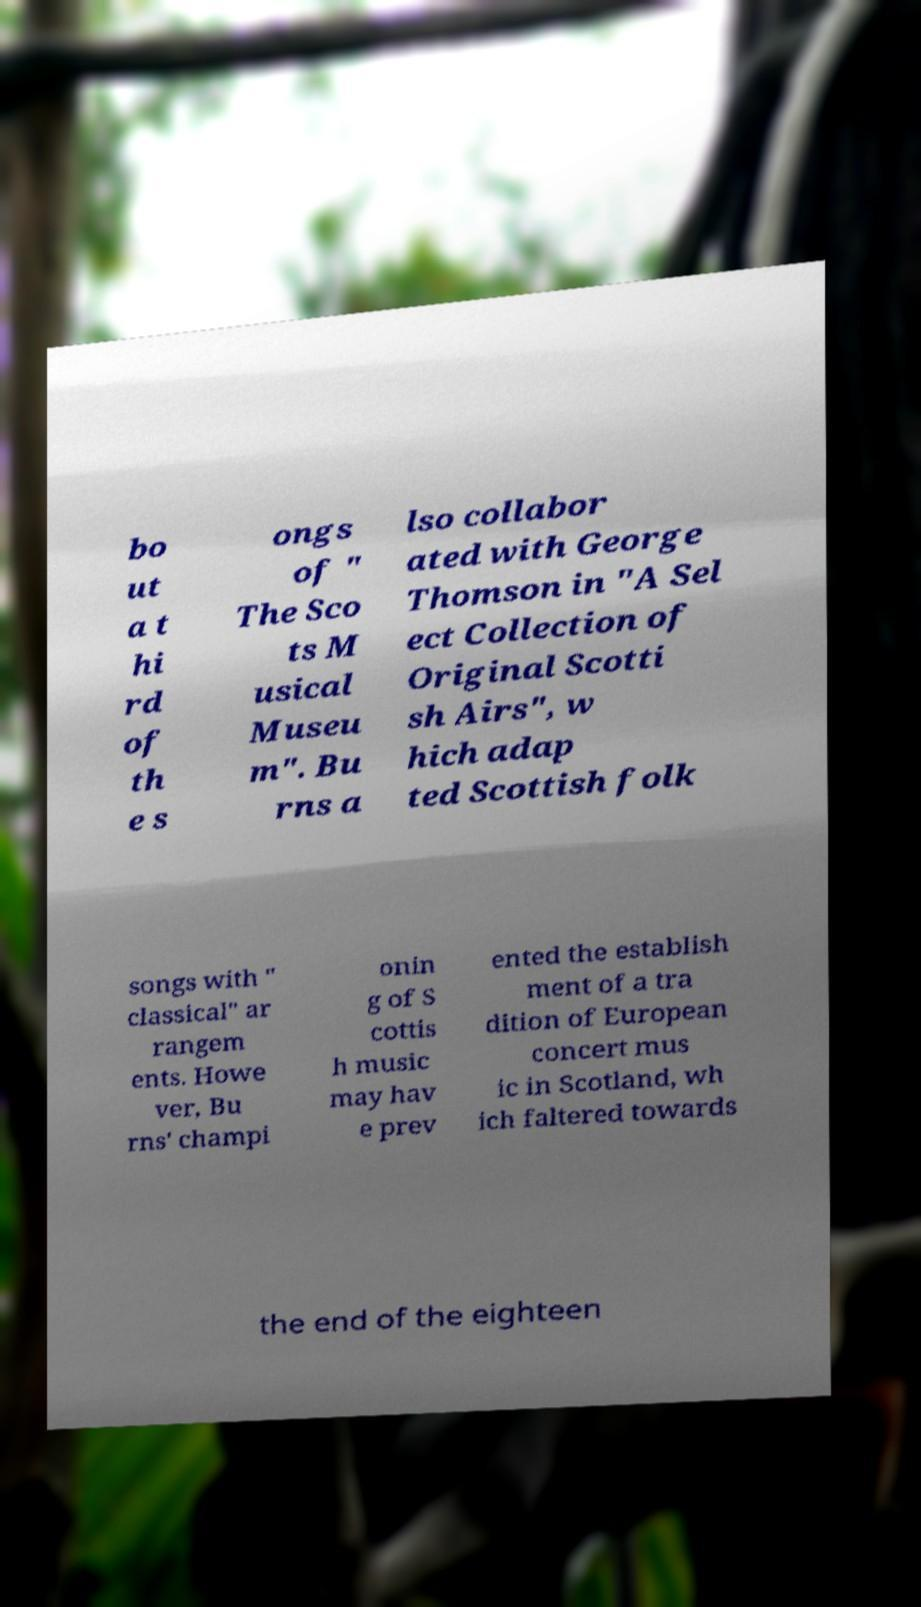Can you read and provide the text displayed in the image?This photo seems to have some interesting text. Can you extract and type it out for me? bo ut a t hi rd of th e s ongs of " The Sco ts M usical Museu m". Bu rns a lso collabor ated with George Thomson in "A Sel ect Collection of Original Scotti sh Airs", w hich adap ted Scottish folk songs with " classical" ar rangem ents. Howe ver, Bu rns' champi onin g of S cottis h music may hav e prev ented the establish ment of a tra dition of European concert mus ic in Scotland, wh ich faltered towards the end of the eighteen 